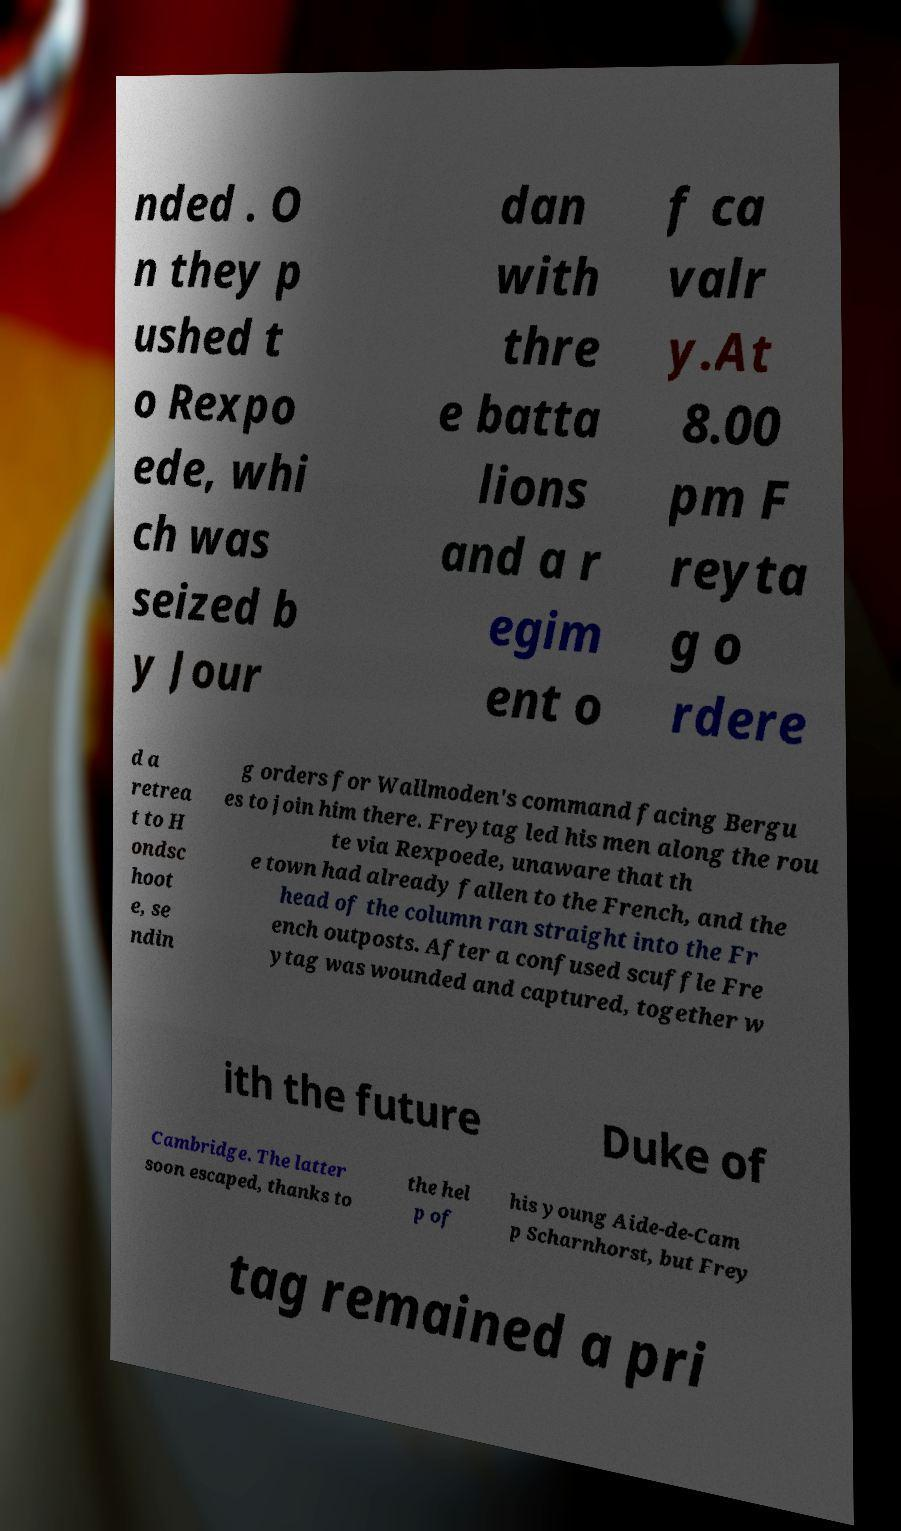There's text embedded in this image that I need extracted. Can you transcribe it verbatim? nded . O n they p ushed t o Rexpo ede, whi ch was seized b y Jour dan with thre e batta lions and a r egim ent o f ca valr y.At 8.00 pm F reyta g o rdere d a retrea t to H ondsc hoot e, se ndin g orders for Wallmoden's command facing Bergu es to join him there. Freytag led his men along the rou te via Rexpoede, unaware that th e town had already fallen to the French, and the head of the column ran straight into the Fr ench outposts. After a confused scuffle Fre ytag was wounded and captured, together w ith the future Duke of Cambridge. The latter soon escaped, thanks to the hel p of his young Aide-de-Cam p Scharnhorst, but Frey tag remained a pri 